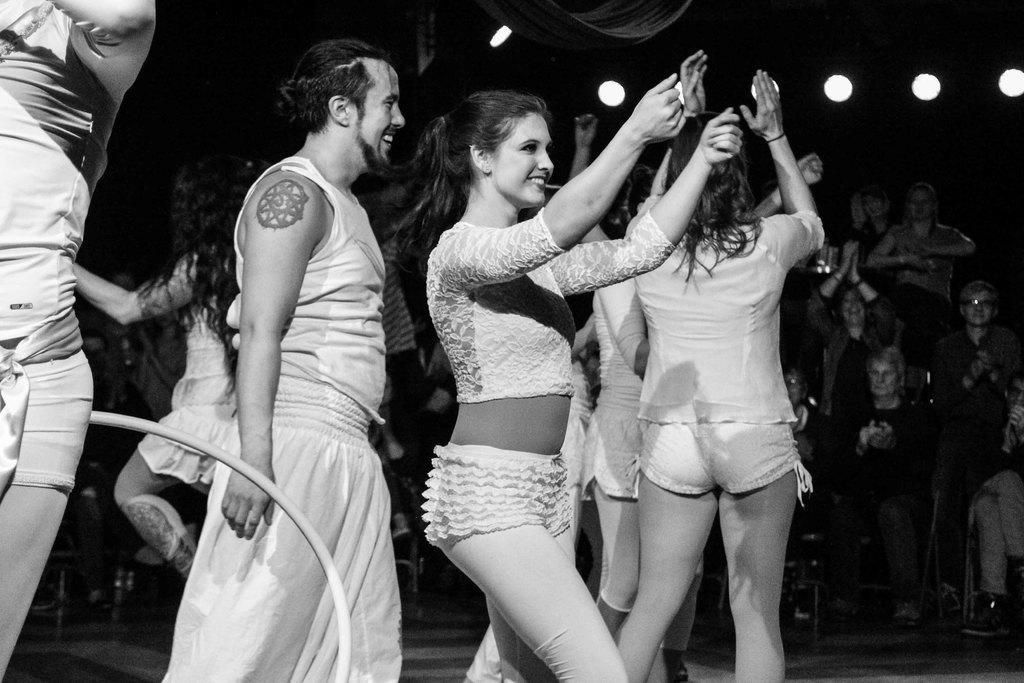Could you give a brief overview of what you see in this image? There are people in motion and we can see object. In the background we can see people and lights and it is dark. 